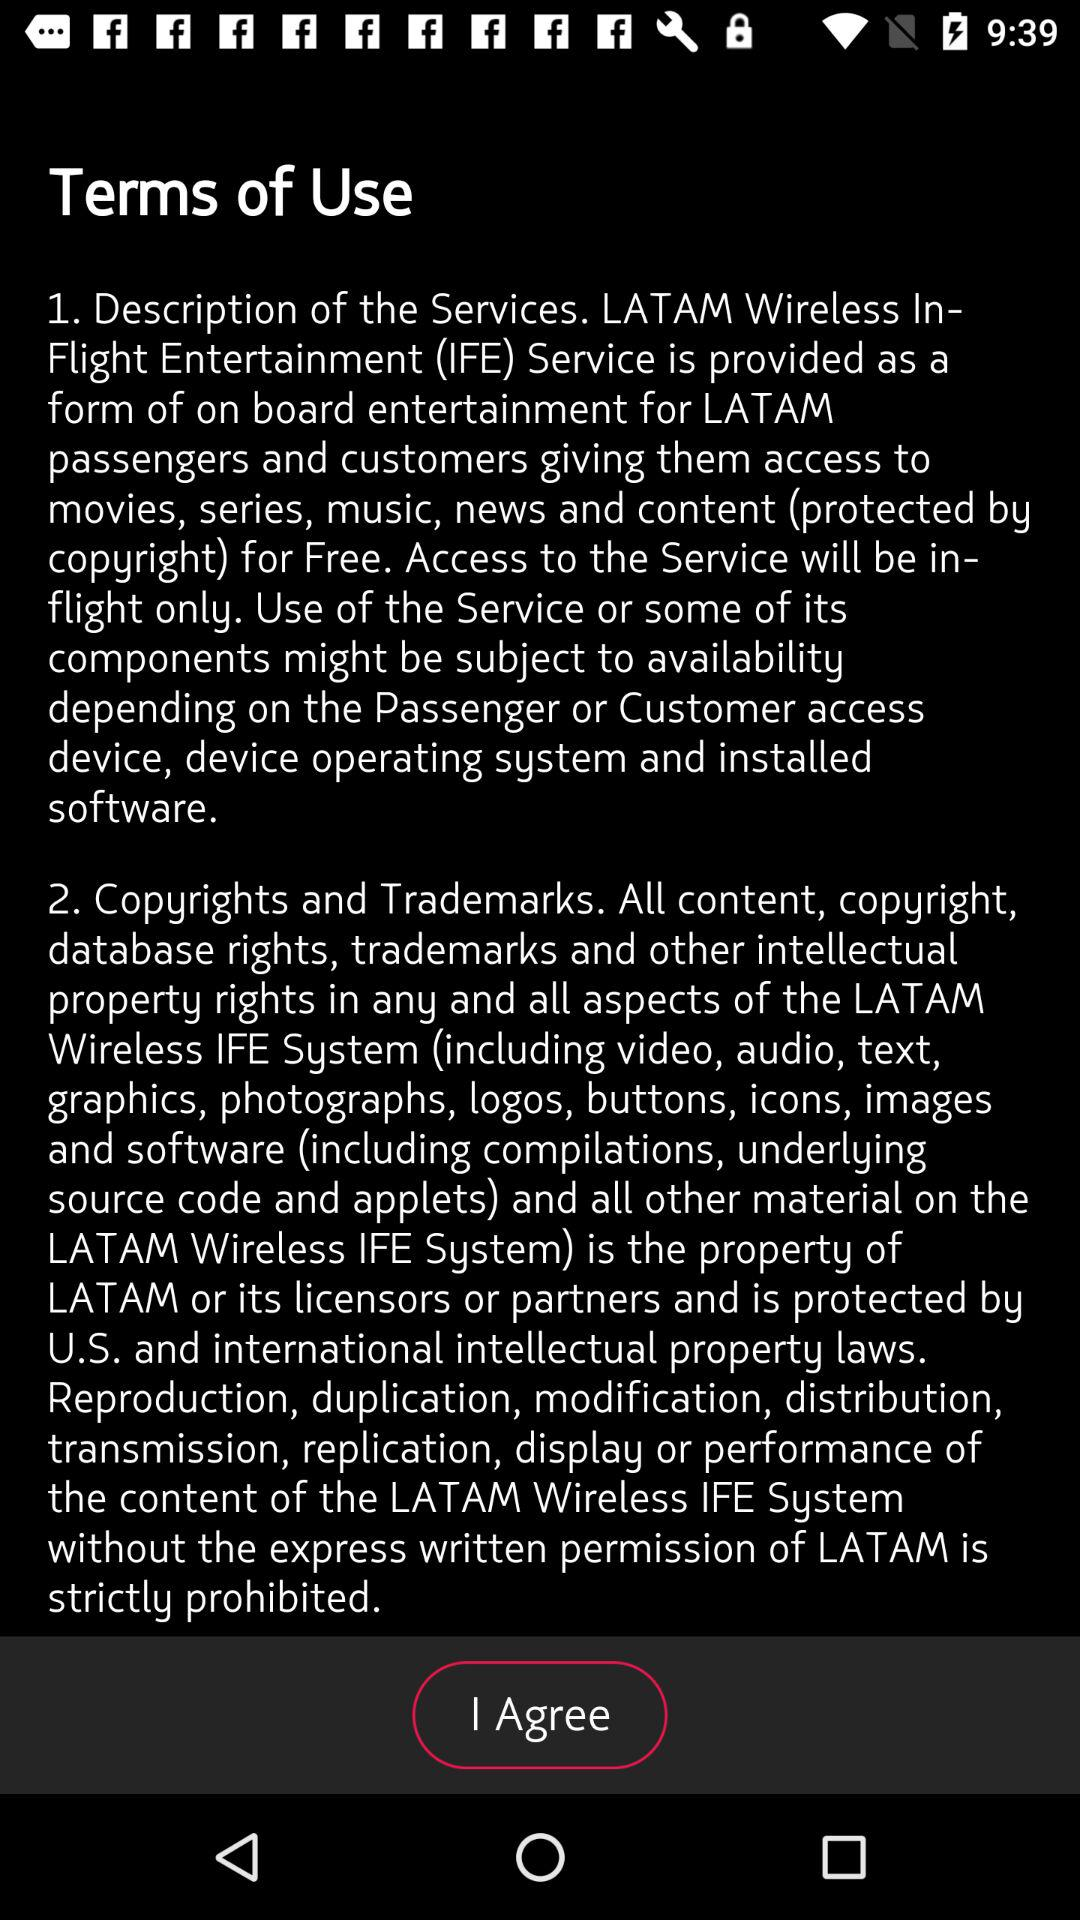How many text blocks are there in the terms of use?
Answer the question using a single word or phrase. 2 